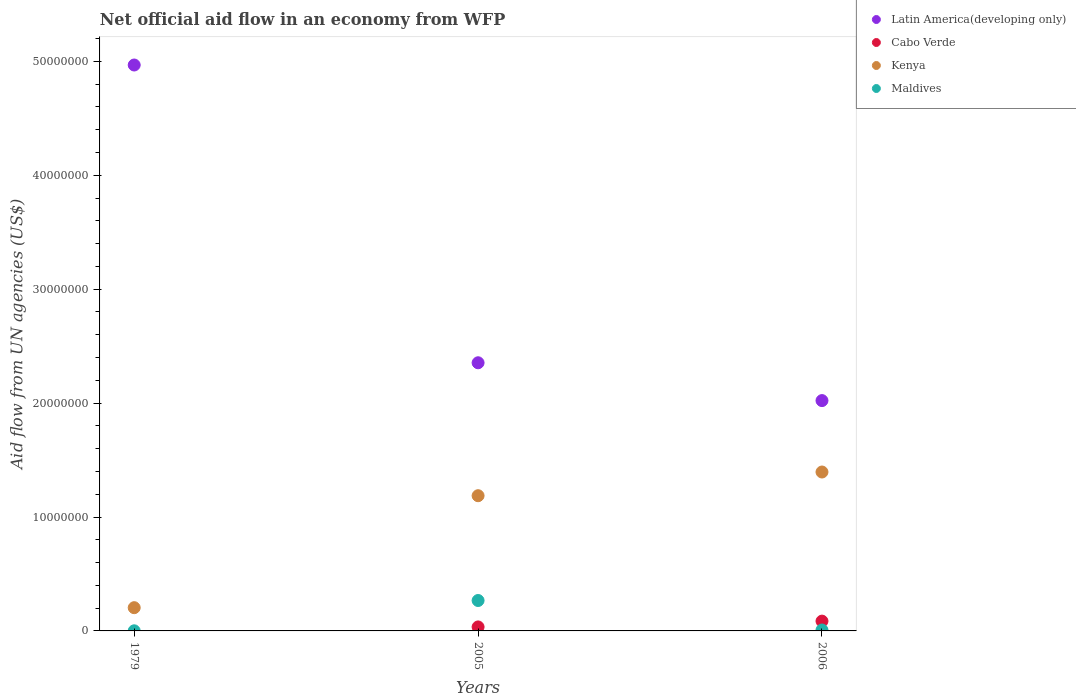Is the number of dotlines equal to the number of legend labels?
Ensure brevity in your answer.  No. What is the net official aid flow in Latin America(developing only) in 1979?
Provide a short and direct response. 4.97e+07. Across all years, what is the maximum net official aid flow in Latin America(developing only)?
Provide a succinct answer. 4.97e+07. Across all years, what is the minimum net official aid flow in Kenya?
Keep it short and to the point. 2.04e+06. In which year was the net official aid flow in Latin America(developing only) maximum?
Ensure brevity in your answer.  1979. What is the total net official aid flow in Kenya in the graph?
Give a very brief answer. 2.79e+07. What is the difference between the net official aid flow in Kenya in 2005 and that in 2006?
Ensure brevity in your answer.  -2.08e+06. What is the difference between the net official aid flow in Cabo Verde in 2006 and the net official aid flow in Latin America(developing only) in 1979?
Offer a very short reply. -4.88e+07. What is the average net official aid flow in Cabo Verde per year?
Make the answer very short. 4.03e+05. In the year 1979, what is the difference between the net official aid flow in Latin America(developing only) and net official aid flow in Maldives?
Ensure brevity in your answer.  4.97e+07. In how many years, is the net official aid flow in Latin America(developing only) greater than 36000000 US$?
Provide a succinct answer. 1. What is the ratio of the net official aid flow in Kenya in 2005 to that in 2006?
Ensure brevity in your answer.  0.85. What is the difference between the highest and the second highest net official aid flow in Maldives?
Keep it short and to the point. 2.59e+06. What is the difference between the highest and the lowest net official aid flow in Cabo Verde?
Your answer should be compact. 8.60e+05. Is the sum of the net official aid flow in Latin America(developing only) in 1979 and 2005 greater than the maximum net official aid flow in Cabo Verde across all years?
Keep it short and to the point. Yes. Is it the case that in every year, the sum of the net official aid flow in Kenya and net official aid flow in Latin America(developing only)  is greater than the net official aid flow in Maldives?
Provide a succinct answer. Yes. Does the net official aid flow in Kenya monotonically increase over the years?
Your answer should be very brief. Yes. Is the net official aid flow in Latin America(developing only) strictly less than the net official aid flow in Kenya over the years?
Your response must be concise. No. How many dotlines are there?
Your response must be concise. 4. How many years are there in the graph?
Offer a very short reply. 3. What is the title of the graph?
Your response must be concise. Net official aid flow in an economy from WFP. What is the label or title of the Y-axis?
Offer a very short reply. Aid flow from UN agencies (US$). What is the Aid flow from UN agencies (US$) in Latin America(developing only) in 1979?
Offer a very short reply. 4.97e+07. What is the Aid flow from UN agencies (US$) of Cabo Verde in 1979?
Make the answer very short. 0. What is the Aid flow from UN agencies (US$) in Kenya in 1979?
Offer a terse response. 2.04e+06. What is the Aid flow from UN agencies (US$) of Latin America(developing only) in 2005?
Your answer should be compact. 2.35e+07. What is the Aid flow from UN agencies (US$) of Kenya in 2005?
Offer a terse response. 1.19e+07. What is the Aid flow from UN agencies (US$) of Maldives in 2005?
Make the answer very short. 2.67e+06. What is the Aid flow from UN agencies (US$) in Latin America(developing only) in 2006?
Offer a very short reply. 2.02e+07. What is the Aid flow from UN agencies (US$) in Cabo Verde in 2006?
Provide a succinct answer. 8.60e+05. What is the Aid flow from UN agencies (US$) in Kenya in 2006?
Your response must be concise. 1.40e+07. Across all years, what is the maximum Aid flow from UN agencies (US$) of Latin America(developing only)?
Give a very brief answer. 4.97e+07. Across all years, what is the maximum Aid flow from UN agencies (US$) of Cabo Verde?
Offer a very short reply. 8.60e+05. Across all years, what is the maximum Aid flow from UN agencies (US$) of Kenya?
Provide a succinct answer. 1.40e+07. Across all years, what is the maximum Aid flow from UN agencies (US$) in Maldives?
Provide a succinct answer. 2.67e+06. Across all years, what is the minimum Aid flow from UN agencies (US$) of Latin America(developing only)?
Your answer should be compact. 2.02e+07. Across all years, what is the minimum Aid flow from UN agencies (US$) in Kenya?
Provide a succinct answer. 2.04e+06. What is the total Aid flow from UN agencies (US$) of Latin America(developing only) in the graph?
Your answer should be very brief. 9.34e+07. What is the total Aid flow from UN agencies (US$) in Cabo Verde in the graph?
Your response must be concise. 1.21e+06. What is the total Aid flow from UN agencies (US$) in Kenya in the graph?
Ensure brevity in your answer.  2.79e+07. What is the total Aid flow from UN agencies (US$) in Maldives in the graph?
Provide a succinct answer. 2.76e+06. What is the difference between the Aid flow from UN agencies (US$) of Latin America(developing only) in 1979 and that in 2005?
Offer a terse response. 2.61e+07. What is the difference between the Aid flow from UN agencies (US$) of Kenya in 1979 and that in 2005?
Give a very brief answer. -9.83e+06. What is the difference between the Aid flow from UN agencies (US$) in Maldives in 1979 and that in 2005?
Make the answer very short. -2.66e+06. What is the difference between the Aid flow from UN agencies (US$) of Latin America(developing only) in 1979 and that in 2006?
Ensure brevity in your answer.  2.95e+07. What is the difference between the Aid flow from UN agencies (US$) of Kenya in 1979 and that in 2006?
Offer a terse response. -1.19e+07. What is the difference between the Aid flow from UN agencies (US$) of Maldives in 1979 and that in 2006?
Give a very brief answer. -7.00e+04. What is the difference between the Aid flow from UN agencies (US$) in Latin America(developing only) in 2005 and that in 2006?
Your answer should be compact. 3.32e+06. What is the difference between the Aid flow from UN agencies (US$) in Cabo Verde in 2005 and that in 2006?
Your answer should be very brief. -5.10e+05. What is the difference between the Aid flow from UN agencies (US$) in Kenya in 2005 and that in 2006?
Offer a terse response. -2.08e+06. What is the difference between the Aid flow from UN agencies (US$) in Maldives in 2005 and that in 2006?
Your answer should be compact. 2.59e+06. What is the difference between the Aid flow from UN agencies (US$) of Latin America(developing only) in 1979 and the Aid flow from UN agencies (US$) of Cabo Verde in 2005?
Offer a terse response. 4.93e+07. What is the difference between the Aid flow from UN agencies (US$) in Latin America(developing only) in 1979 and the Aid flow from UN agencies (US$) in Kenya in 2005?
Ensure brevity in your answer.  3.78e+07. What is the difference between the Aid flow from UN agencies (US$) in Latin America(developing only) in 1979 and the Aid flow from UN agencies (US$) in Maldives in 2005?
Your answer should be very brief. 4.70e+07. What is the difference between the Aid flow from UN agencies (US$) in Kenya in 1979 and the Aid flow from UN agencies (US$) in Maldives in 2005?
Your response must be concise. -6.30e+05. What is the difference between the Aid flow from UN agencies (US$) in Latin America(developing only) in 1979 and the Aid flow from UN agencies (US$) in Cabo Verde in 2006?
Your answer should be compact. 4.88e+07. What is the difference between the Aid flow from UN agencies (US$) in Latin America(developing only) in 1979 and the Aid flow from UN agencies (US$) in Kenya in 2006?
Offer a terse response. 3.57e+07. What is the difference between the Aid flow from UN agencies (US$) of Latin America(developing only) in 1979 and the Aid flow from UN agencies (US$) of Maldives in 2006?
Your answer should be compact. 4.96e+07. What is the difference between the Aid flow from UN agencies (US$) in Kenya in 1979 and the Aid flow from UN agencies (US$) in Maldives in 2006?
Your answer should be very brief. 1.96e+06. What is the difference between the Aid flow from UN agencies (US$) in Latin America(developing only) in 2005 and the Aid flow from UN agencies (US$) in Cabo Verde in 2006?
Ensure brevity in your answer.  2.27e+07. What is the difference between the Aid flow from UN agencies (US$) of Latin America(developing only) in 2005 and the Aid flow from UN agencies (US$) of Kenya in 2006?
Provide a succinct answer. 9.59e+06. What is the difference between the Aid flow from UN agencies (US$) of Latin America(developing only) in 2005 and the Aid flow from UN agencies (US$) of Maldives in 2006?
Ensure brevity in your answer.  2.35e+07. What is the difference between the Aid flow from UN agencies (US$) of Cabo Verde in 2005 and the Aid flow from UN agencies (US$) of Kenya in 2006?
Offer a very short reply. -1.36e+07. What is the difference between the Aid flow from UN agencies (US$) in Cabo Verde in 2005 and the Aid flow from UN agencies (US$) in Maldives in 2006?
Give a very brief answer. 2.70e+05. What is the difference between the Aid flow from UN agencies (US$) in Kenya in 2005 and the Aid flow from UN agencies (US$) in Maldives in 2006?
Provide a short and direct response. 1.18e+07. What is the average Aid flow from UN agencies (US$) of Latin America(developing only) per year?
Keep it short and to the point. 3.11e+07. What is the average Aid flow from UN agencies (US$) of Cabo Verde per year?
Give a very brief answer. 4.03e+05. What is the average Aid flow from UN agencies (US$) of Kenya per year?
Give a very brief answer. 9.29e+06. What is the average Aid flow from UN agencies (US$) in Maldives per year?
Offer a terse response. 9.20e+05. In the year 1979, what is the difference between the Aid flow from UN agencies (US$) in Latin America(developing only) and Aid flow from UN agencies (US$) in Kenya?
Provide a short and direct response. 4.76e+07. In the year 1979, what is the difference between the Aid flow from UN agencies (US$) in Latin America(developing only) and Aid flow from UN agencies (US$) in Maldives?
Ensure brevity in your answer.  4.97e+07. In the year 1979, what is the difference between the Aid flow from UN agencies (US$) in Kenya and Aid flow from UN agencies (US$) in Maldives?
Offer a terse response. 2.03e+06. In the year 2005, what is the difference between the Aid flow from UN agencies (US$) in Latin America(developing only) and Aid flow from UN agencies (US$) in Cabo Verde?
Offer a terse response. 2.32e+07. In the year 2005, what is the difference between the Aid flow from UN agencies (US$) of Latin America(developing only) and Aid flow from UN agencies (US$) of Kenya?
Make the answer very short. 1.17e+07. In the year 2005, what is the difference between the Aid flow from UN agencies (US$) in Latin America(developing only) and Aid flow from UN agencies (US$) in Maldives?
Your answer should be compact. 2.09e+07. In the year 2005, what is the difference between the Aid flow from UN agencies (US$) in Cabo Verde and Aid flow from UN agencies (US$) in Kenya?
Keep it short and to the point. -1.15e+07. In the year 2005, what is the difference between the Aid flow from UN agencies (US$) in Cabo Verde and Aid flow from UN agencies (US$) in Maldives?
Ensure brevity in your answer.  -2.32e+06. In the year 2005, what is the difference between the Aid flow from UN agencies (US$) in Kenya and Aid flow from UN agencies (US$) in Maldives?
Keep it short and to the point. 9.20e+06. In the year 2006, what is the difference between the Aid flow from UN agencies (US$) of Latin America(developing only) and Aid flow from UN agencies (US$) of Cabo Verde?
Offer a very short reply. 1.94e+07. In the year 2006, what is the difference between the Aid flow from UN agencies (US$) in Latin America(developing only) and Aid flow from UN agencies (US$) in Kenya?
Provide a short and direct response. 6.27e+06. In the year 2006, what is the difference between the Aid flow from UN agencies (US$) in Latin America(developing only) and Aid flow from UN agencies (US$) in Maldives?
Ensure brevity in your answer.  2.01e+07. In the year 2006, what is the difference between the Aid flow from UN agencies (US$) of Cabo Verde and Aid flow from UN agencies (US$) of Kenya?
Your response must be concise. -1.31e+07. In the year 2006, what is the difference between the Aid flow from UN agencies (US$) in Cabo Verde and Aid flow from UN agencies (US$) in Maldives?
Ensure brevity in your answer.  7.80e+05. In the year 2006, what is the difference between the Aid flow from UN agencies (US$) in Kenya and Aid flow from UN agencies (US$) in Maldives?
Keep it short and to the point. 1.39e+07. What is the ratio of the Aid flow from UN agencies (US$) of Latin America(developing only) in 1979 to that in 2005?
Make the answer very short. 2.11. What is the ratio of the Aid flow from UN agencies (US$) of Kenya in 1979 to that in 2005?
Your response must be concise. 0.17. What is the ratio of the Aid flow from UN agencies (US$) of Maldives in 1979 to that in 2005?
Your response must be concise. 0. What is the ratio of the Aid flow from UN agencies (US$) of Latin America(developing only) in 1979 to that in 2006?
Give a very brief answer. 2.46. What is the ratio of the Aid flow from UN agencies (US$) of Kenya in 1979 to that in 2006?
Your answer should be compact. 0.15. What is the ratio of the Aid flow from UN agencies (US$) in Latin America(developing only) in 2005 to that in 2006?
Provide a short and direct response. 1.16. What is the ratio of the Aid flow from UN agencies (US$) in Cabo Verde in 2005 to that in 2006?
Offer a terse response. 0.41. What is the ratio of the Aid flow from UN agencies (US$) of Kenya in 2005 to that in 2006?
Keep it short and to the point. 0.85. What is the ratio of the Aid flow from UN agencies (US$) in Maldives in 2005 to that in 2006?
Offer a very short reply. 33.38. What is the difference between the highest and the second highest Aid flow from UN agencies (US$) in Latin America(developing only)?
Offer a very short reply. 2.61e+07. What is the difference between the highest and the second highest Aid flow from UN agencies (US$) in Kenya?
Offer a terse response. 2.08e+06. What is the difference between the highest and the second highest Aid flow from UN agencies (US$) in Maldives?
Offer a terse response. 2.59e+06. What is the difference between the highest and the lowest Aid flow from UN agencies (US$) in Latin America(developing only)?
Give a very brief answer. 2.95e+07. What is the difference between the highest and the lowest Aid flow from UN agencies (US$) in Cabo Verde?
Your response must be concise. 8.60e+05. What is the difference between the highest and the lowest Aid flow from UN agencies (US$) of Kenya?
Provide a succinct answer. 1.19e+07. What is the difference between the highest and the lowest Aid flow from UN agencies (US$) in Maldives?
Your answer should be compact. 2.66e+06. 